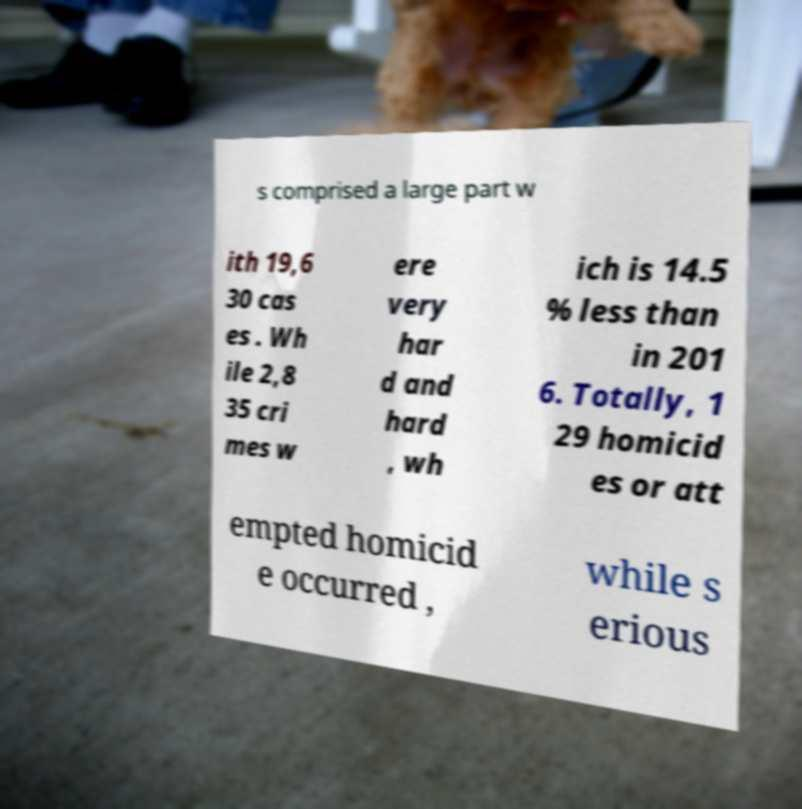I need the written content from this picture converted into text. Can you do that? s comprised a large part w ith 19,6 30 cas es . Wh ile 2,8 35 cri mes w ere very har d and hard , wh ich is 14.5 % less than in 201 6. Totally, 1 29 homicid es or att empted homicid e occurred , while s erious 